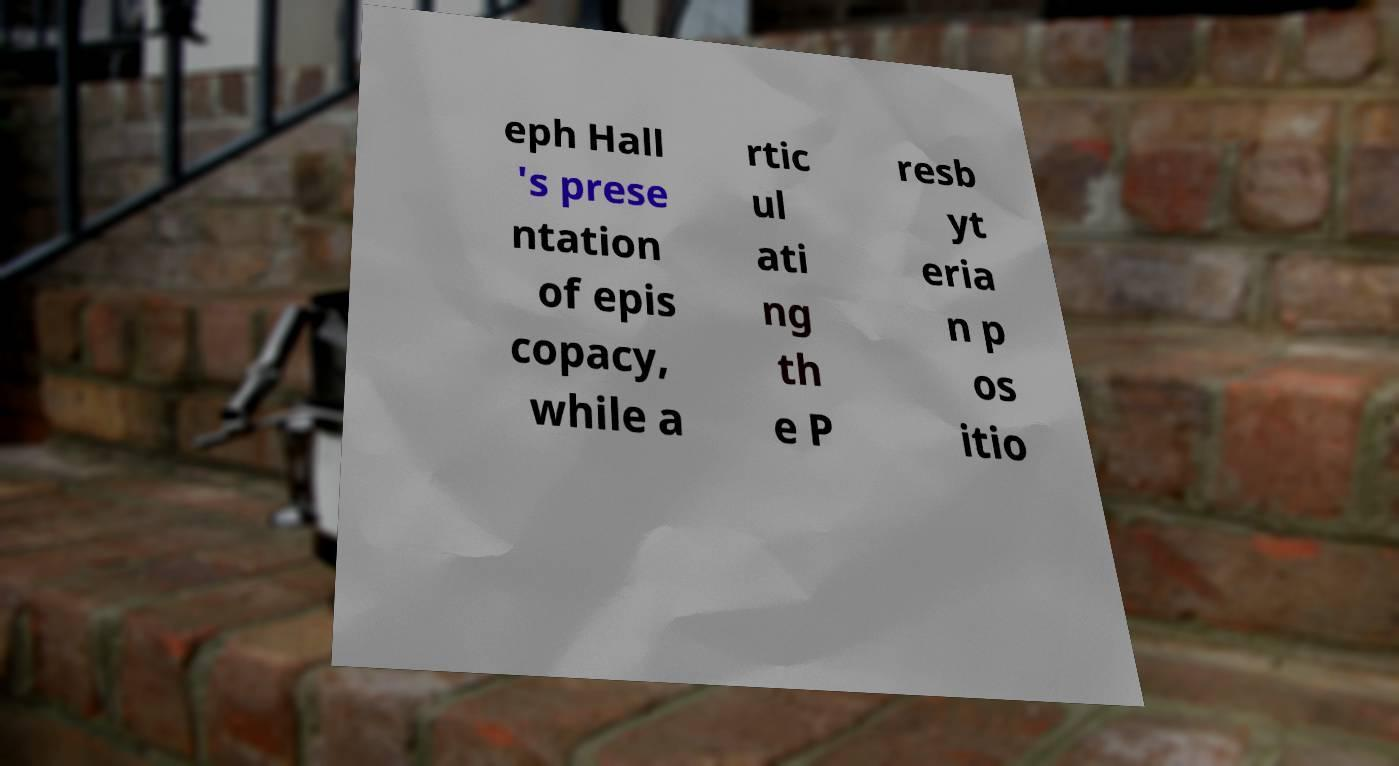For documentation purposes, I need the text within this image transcribed. Could you provide that? eph Hall 's prese ntation of epis copacy, while a rtic ul ati ng th e P resb yt eria n p os itio 